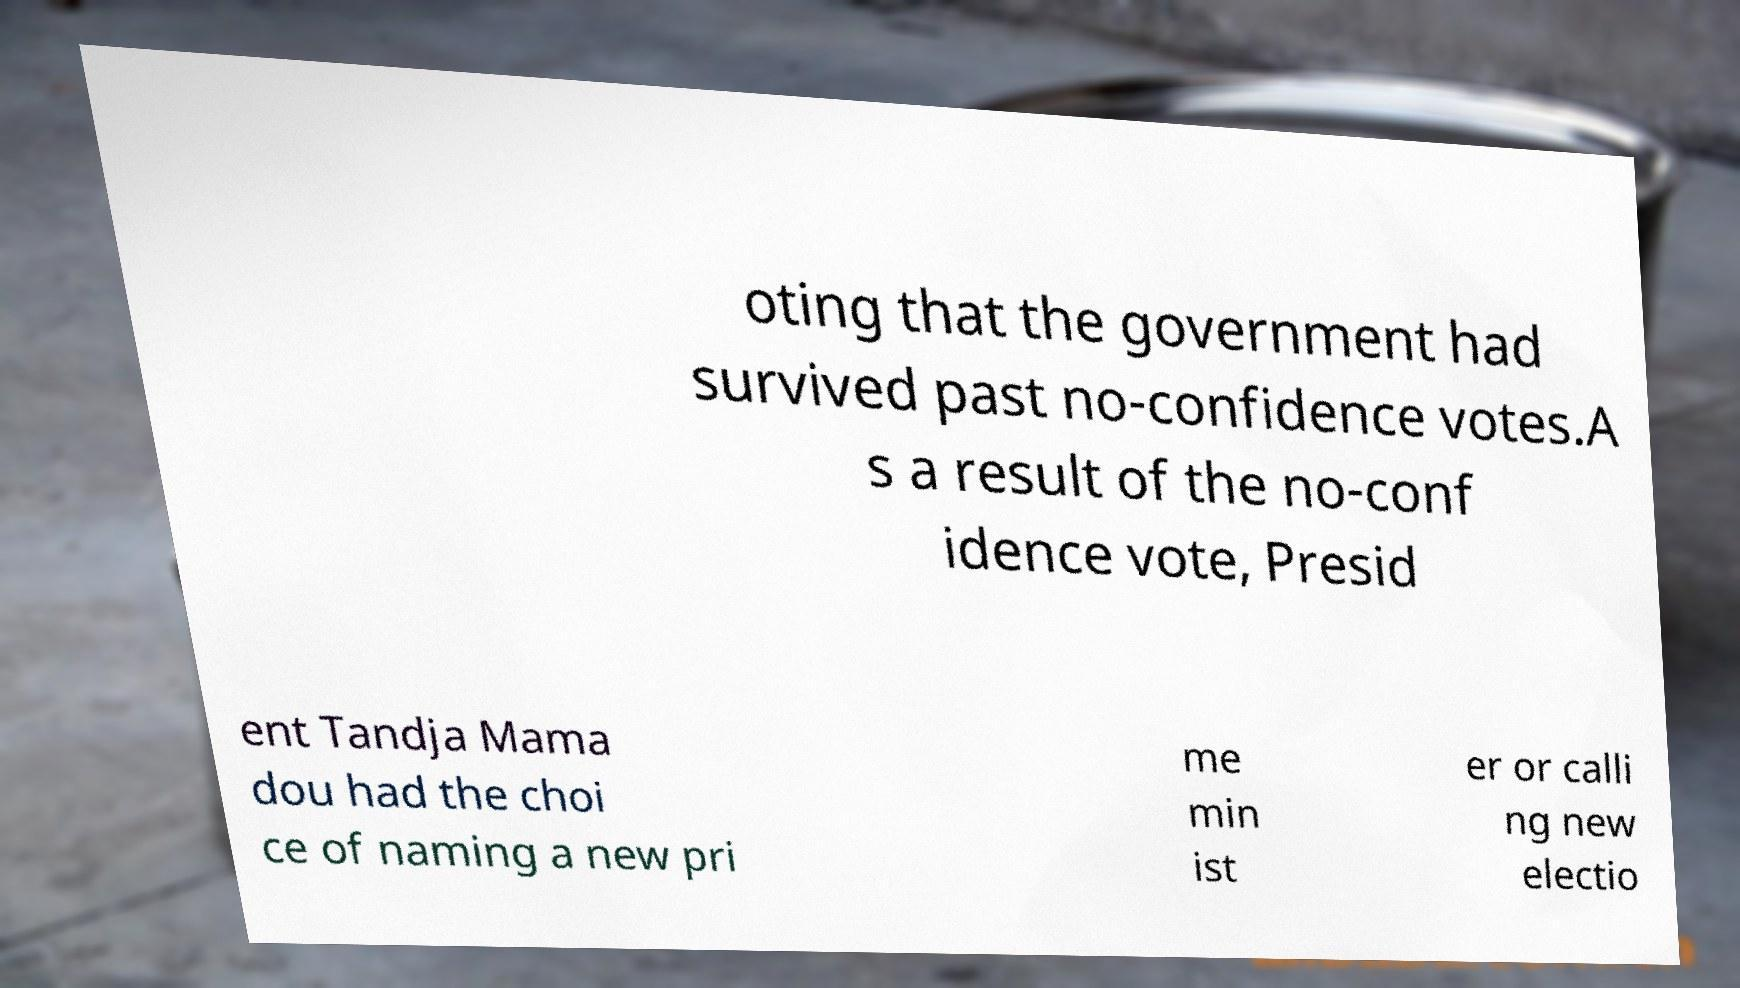Can you accurately transcribe the text from the provided image for me? oting that the government had survived past no-confidence votes.A s a result of the no-conf idence vote, Presid ent Tandja Mama dou had the choi ce of naming a new pri me min ist er or calli ng new electio 